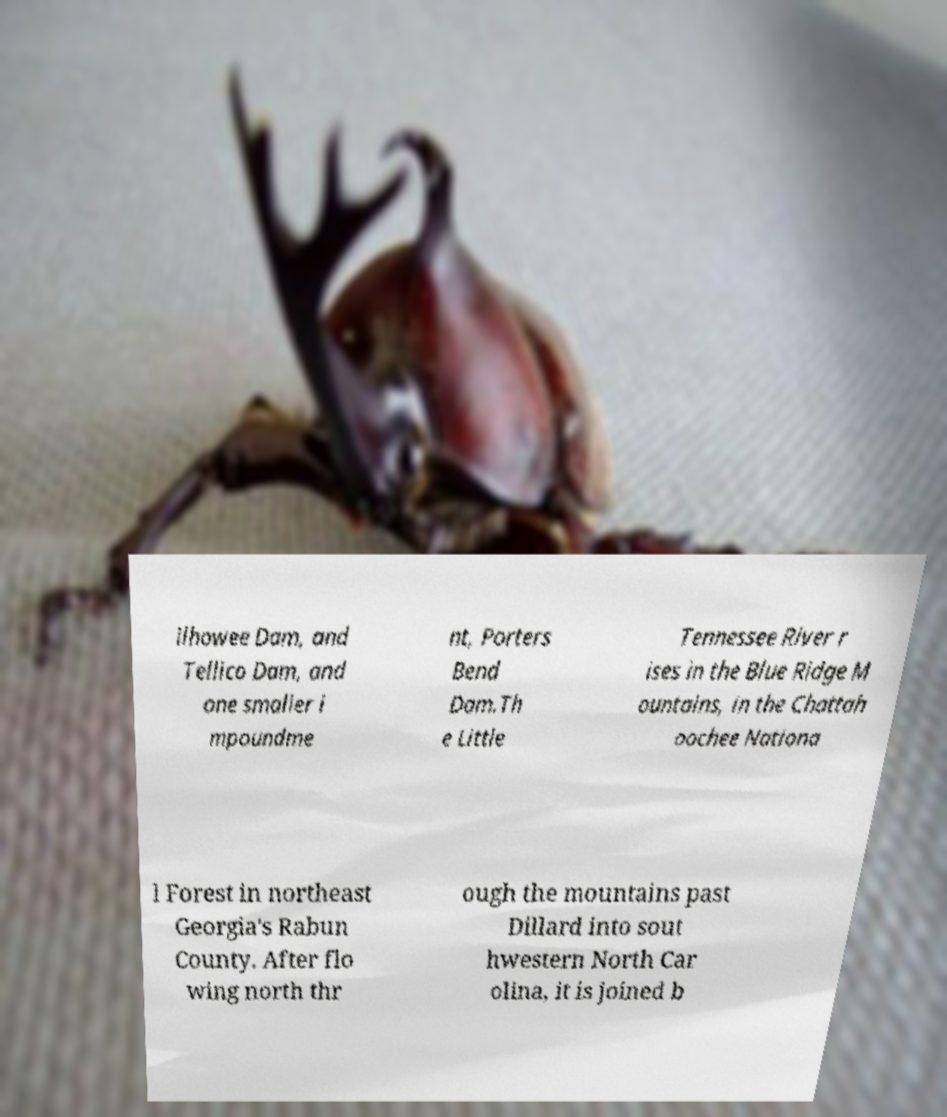I need the written content from this picture converted into text. Can you do that? ilhowee Dam, and Tellico Dam, and one smaller i mpoundme nt, Porters Bend Dam.Th e Little Tennessee River r ises in the Blue Ridge M ountains, in the Chattah oochee Nationa l Forest in northeast Georgia's Rabun County. After flo wing north thr ough the mountains past Dillard into sout hwestern North Car olina, it is joined b 